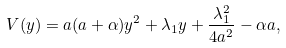Convert formula to latex. <formula><loc_0><loc_0><loc_500><loc_500>V ( y ) = a ( a + \alpha ) y ^ { 2 } + \lambda _ { 1 } y + \frac { \lambda _ { 1 } ^ { 2 } } { 4 a ^ { 2 } } - \alpha a ,</formula> 